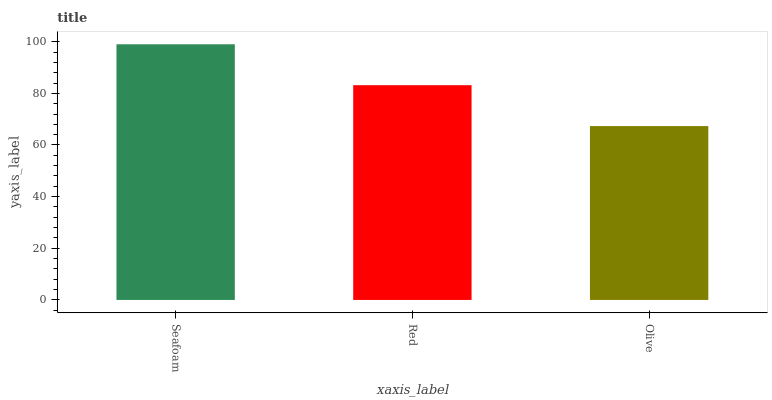Is Olive the minimum?
Answer yes or no. Yes. Is Seafoam the maximum?
Answer yes or no. Yes. Is Red the minimum?
Answer yes or no. No. Is Red the maximum?
Answer yes or no. No. Is Seafoam greater than Red?
Answer yes or no. Yes. Is Red less than Seafoam?
Answer yes or no. Yes. Is Red greater than Seafoam?
Answer yes or no. No. Is Seafoam less than Red?
Answer yes or no. No. Is Red the high median?
Answer yes or no. Yes. Is Red the low median?
Answer yes or no. Yes. Is Olive the high median?
Answer yes or no. No. Is Olive the low median?
Answer yes or no. No. 